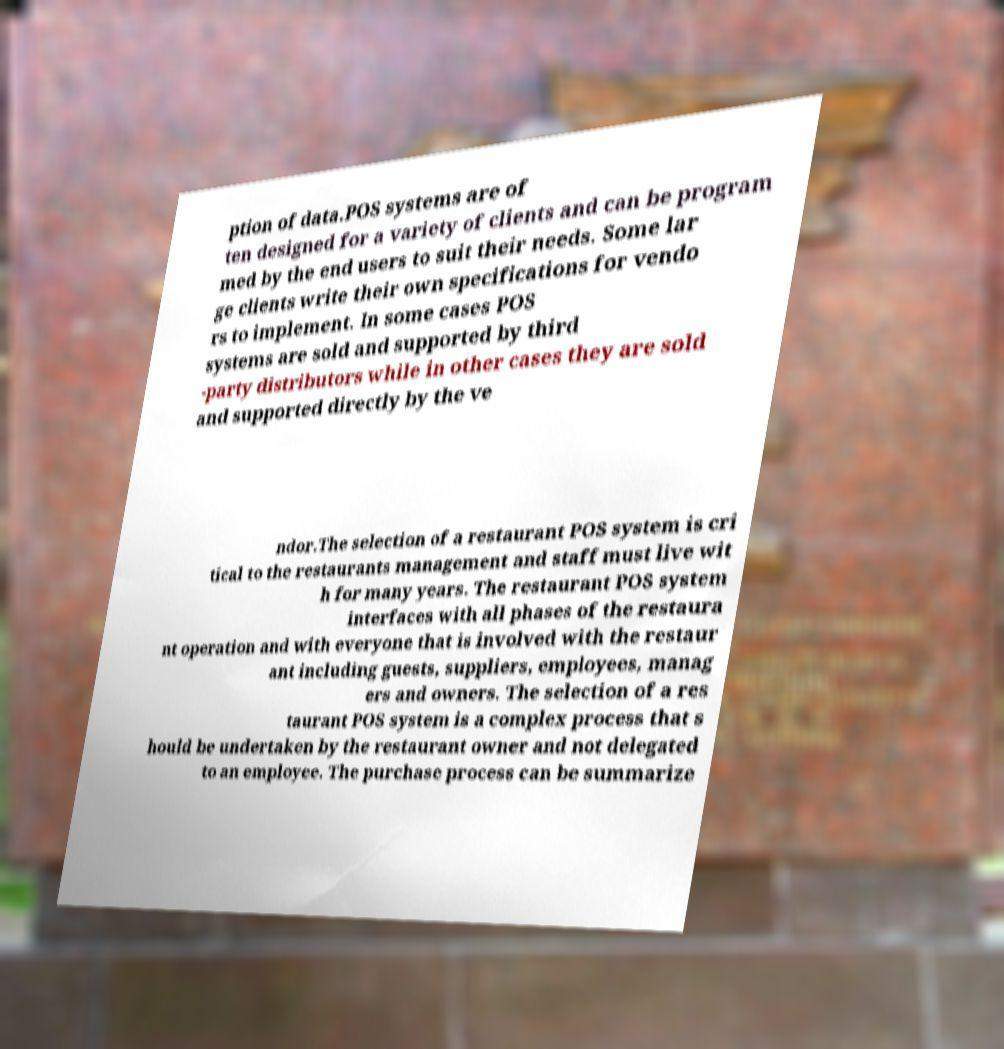Can you read and provide the text displayed in the image?This photo seems to have some interesting text. Can you extract and type it out for me? ption of data.POS systems are of ten designed for a variety of clients and can be program med by the end users to suit their needs. Some lar ge clients write their own specifications for vendo rs to implement. In some cases POS systems are sold and supported by third -party distributors while in other cases they are sold and supported directly by the ve ndor.The selection of a restaurant POS system is cri tical to the restaurants management and staff must live wit h for many years. The restaurant POS system interfaces with all phases of the restaura nt operation and with everyone that is involved with the restaur ant including guests, suppliers, employees, manag ers and owners. The selection of a res taurant POS system is a complex process that s hould be undertaken by the restaurant owner and not delegated to an employee. The purchase process can be summarize 